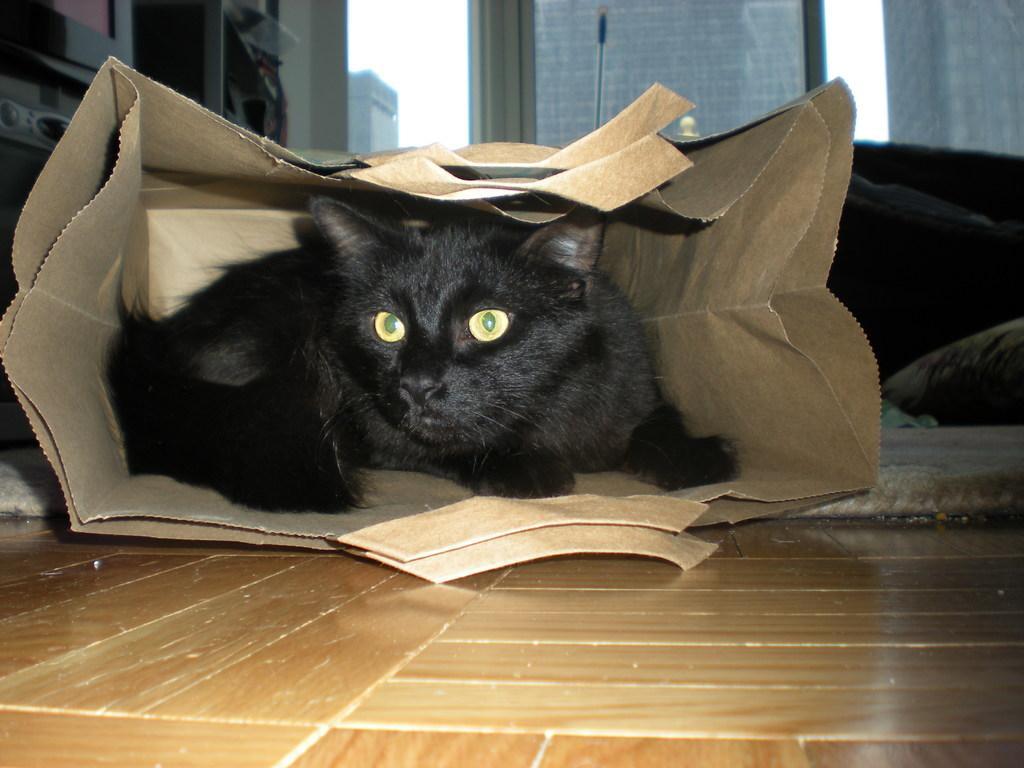Can you describe this image briefly? In this image we can see the black color cat inside the paper cover. We can also see the mat, floor and also glass windows and through the glass windows we can see the windows and also the sky. 